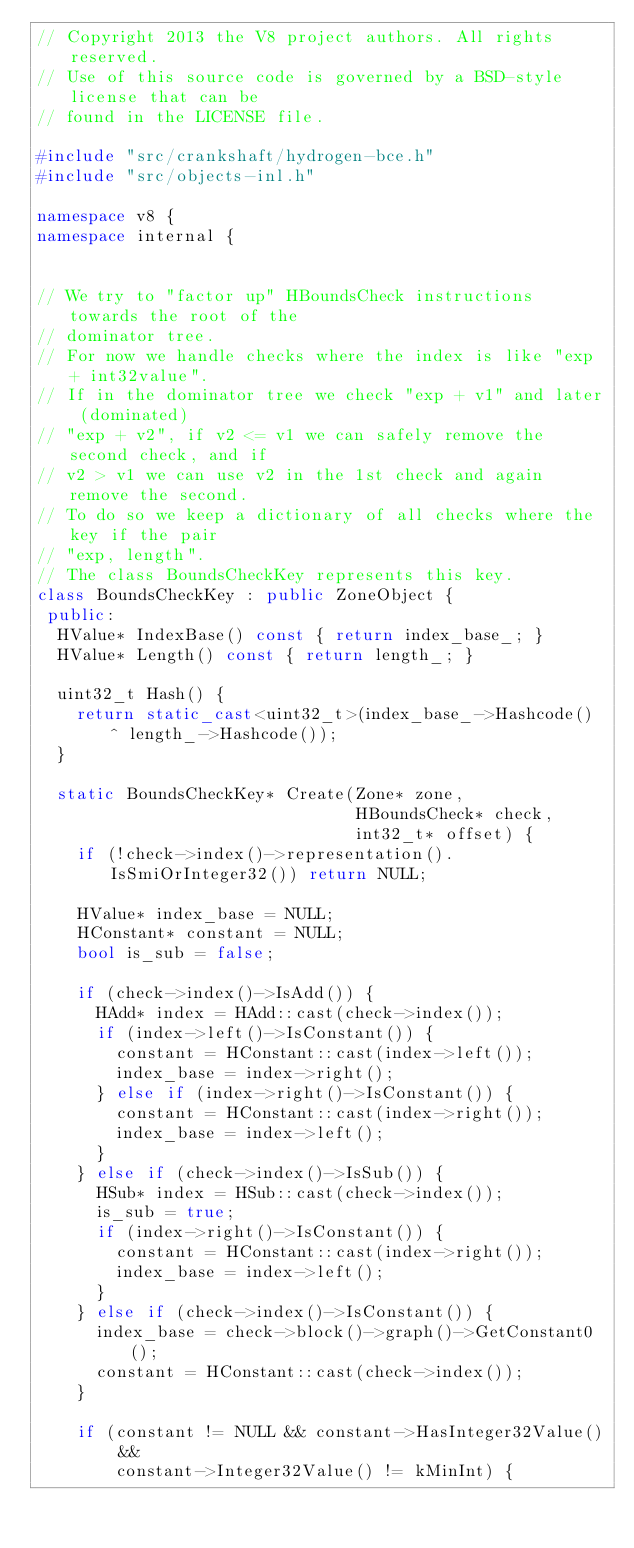<code> <loc_0><loc_0><loc_500><loc_500><_C++_>// Copyright 2013 the V8 project authors. All rights reserved.
// Use of this source code is governed by a BSD-style license that can be
// found in the LICENSE file.

#include "src/crankshaft/hydrogen-bce.h"
#include "src/objects-inl.h"

namespace v8 {
namespace internal {


// We try to "factor up" HBoundsCheck instructions towards the root of the
// dominator tree.
// For now we handle checks where the index is like "exp + int32value".
// If in the dominator tree we check "exp + v1" and later (dominated)
// "exp + v2", if v2 <= v1 we can safely remove the second check, and if
// v2 > v1 we can use v2 in the 1st check and again remove the second.
// To do so we keep a dictionary of all checks where the key if the pair
// "exp, length".
// The class BoundsCheckKey represents this key.
class BoundsCheckKey : public ZoneObject {
 public:
  HValue* IndexBase() const { return index_base_; }
  HValue* Length() const { return length_; }

  uint32_t Hash() {
    return static_cast<uint32_t>(index_base_->Hashcode() ^ length_->Hashcode());
  }

  static BoundsCheckKey* Create(Zone* zone,
                                HBoundsCheck* check,
                                int32_t* offset) {
    if (!check->index()->representation().IsSmiOrInteger32()) return NULL;

    HValue* index_base = NULL;
    HConstant* constant = NULL;
    bool is_sub = false;

    if (check->index()->IsAdd()) {
      HAdd* index = HAdd::cast(check->index());
      if (index->left()->IsConstant()) {
        constant = HConstant::cast(index->left());
        index_base = index->right();
      } else if (index->right()->IsConstant()) {
        constant = HConstant::cast(index->right());
        index_base = index->left();
      }
    } else if (check->index()->IsSub()) {
      HSub* index = HSub::cast(check->index());
      is_sub = true;
      if (index->right()->IsConstant()) {
        constant = HConstant::cast(index->right());
        index_base = index->left();
      }
    } else if (check->index()->IsConstant()) {
      index_base = check->block()->graph()->GetConstant0();
      constant = HConstant::cast(check->index());
    }

    if (constant != NULL && constant->HasInteger32Value() &&
        constant->Integer32Value() != kMinInt) {</code> 